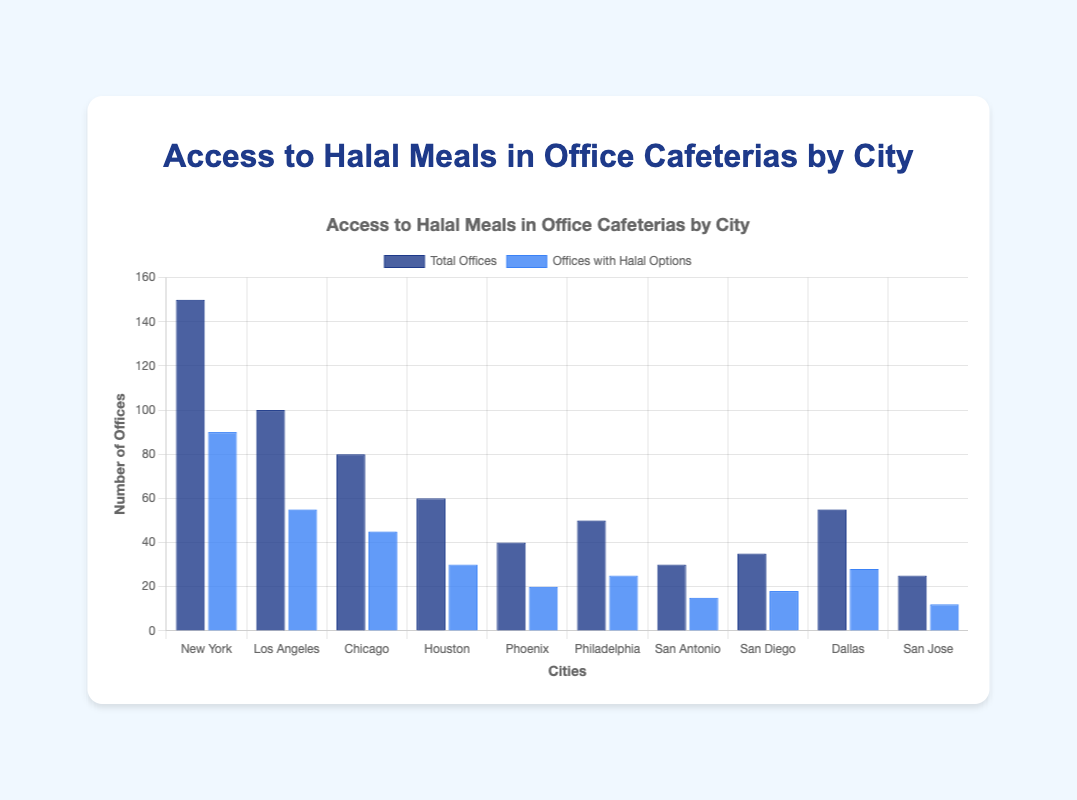Which city has the highest number of offices with halal options? By looking at the bars labeled "Offices with Halal Options," the city with the tallest bar represents the highest number. For "Offices with Halal Options," New York has the tallest bar.
Answer: New York What is the total number of offices with halal options in New York and Los Angeles combined? Summing the values for New York (90) and Los Angeles (55) gives us the total: 90 + 55 = 145.
Answer: 145 Which city has the smallest difference between total offices and offices with halal options? Subtracting the number of offices with halal options from the total offices for each city, the city with the smallest result is desired. New York: 150 - 90 = 60, Los Angeles: 100 - 55 = 45, Chicago: 80 - 45 = 35, Houston: 60 - 30 = 30, Phoenix: 40 - 20 = 20, Philadelphia: 50 - 25 = 25, San Antonio: 30 - 15 = 15, San Diego: 35 - 18 = 17, Dallas: 55 - 28 = 27, San Jose: 25 - 12 = 13. The smallest difference is for San Jose (13).
Answer: San Jose What proportion of offices in Chicago have halal options? Dividing the number of offices with halal options by the total number of offices: 45 / 80 = 0.5625, or 56.25%.
Answer: 56.25% Between Houston and Philadelphia, which city has a higher percentage of offices providing halal options? Calculating the percentage of halal options: Houston (30/60 = 0.5 or 50%) and Philadelphia (25/50 = 0.5 or 50%), both cities have the same percentage.
Answer: Both Compare the number of offices with halal options in Phoenix and San Antonio. Which city has more? By observing the heights of the bars for "Offices with Halal Options," Phoenix has 20 and San Antonio has 15. Phoenix has more.
Answer: Phoenix How many more total offices does New York have compared to San Jose? Subtract the number of total offices in San Jose from New York’s total offices: 150 - 25 = 125.
Answer: 125 What is the average number of offices with halal options across all cities? Summing the "offices with halal options" from all cities and then dividing by the number of cities: (90 + 55 + 45 + 30 + 20 + 25 + 15 + 18 + 28 + 12) / 10 = 33.8.
Answer: 33.8 